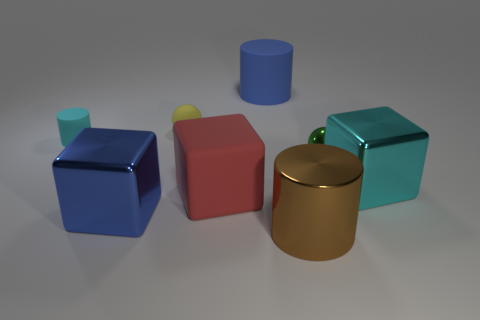Is the number of large metal cylinders in front of the matte block greater than the number of yellow objects that are to the right of the yellow object?
Give a very brief answer. Yes. There is a rubber thing that is both in front of the yellow thing and to the left of the red matte cube; what is its size?
Provide a succinct answer. Small. How many cubes have the same size as the brown shiny cylinder?
Your answer should be very brief. 3. There is a large thing that is the same color as the tiny cylinder; what is its material?
Offer a terse response. Metal. There is a green thing that is in front of the blue rubber cylinder; is it the same shape as the cyan matte object?
Your answer should be very brief. No. Are there fewer big brown metal things behind the large red rubber cube than tiny yellow shiny balls?
Offer a terse response. No. Is there a big metallic block of the same color as the rubber block?
Keep it short and to the point. No. Is the shape of the yellow rubber object the same as the green shiny thing right of the large brown thing?
Ensure brevity in your answer.  Yes. Is there a large red cylinder made of the same material as the small yellow ball?
Keep it short and to the point. No. There is a cube on the right side of the cylinder that is in front of the small green thing; is there a shiny block on the right side of it?
Provide a short and direct response. No. 